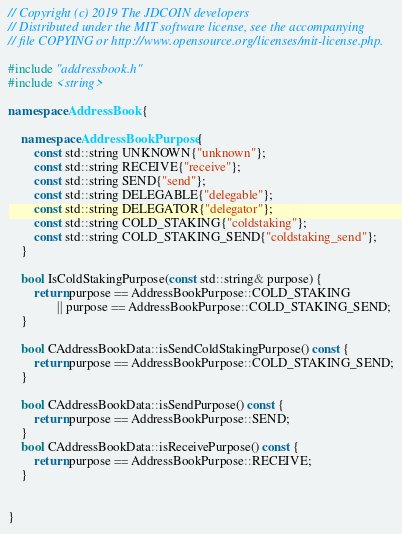<code> <loc_0><loc_0><loc_500><loc_500><_C++_>// Copyright (c) 2019 The JDCOIN developers
// Distributed under the MIT software license, see the accompanying
// file COPYING or http://www.opensource.org/licenses/mit-license.php.

#include "addressbook.h"
#include <string>

namespace AddressBook {

    namespace AddressBookPurpose {
        const std::string UNKNOWN{"unknown"};
        const std::string RECEIVE{"receive"};
        const std::string SEND{"send"};
        const std::string DELEGABLE{"delegable"};
        const std::string DELEGATOR{"delegator"};
        const std::string COLD_STAKING{"coldstaking"};
        const std::string COLD_STAKING_SEND{"coldstaking_send"};
    }

    bool IsColdStakingPurpose(const std::string& purpose) {
        return purpose == AddressBookPurpose::COLD_STAKING
               || purpose == AddressBookPurpose::COLD_STAKING_SEND;
    }

    bool CAddressBookData::isSendColdStakingPurpose() const {
        return purpose == AddressBookPurpose::COLD_STAKING_SEND;
    }

    bool CAddressBookData::isSendPurpose() const {
        return purpose == AddressBookPurpose::SEND;
    }
    bool CAddressBookData::isReceivePurpose() const {
        return purpose == AddressBookPurpose::RECEIVE;
    }


}

</code> 